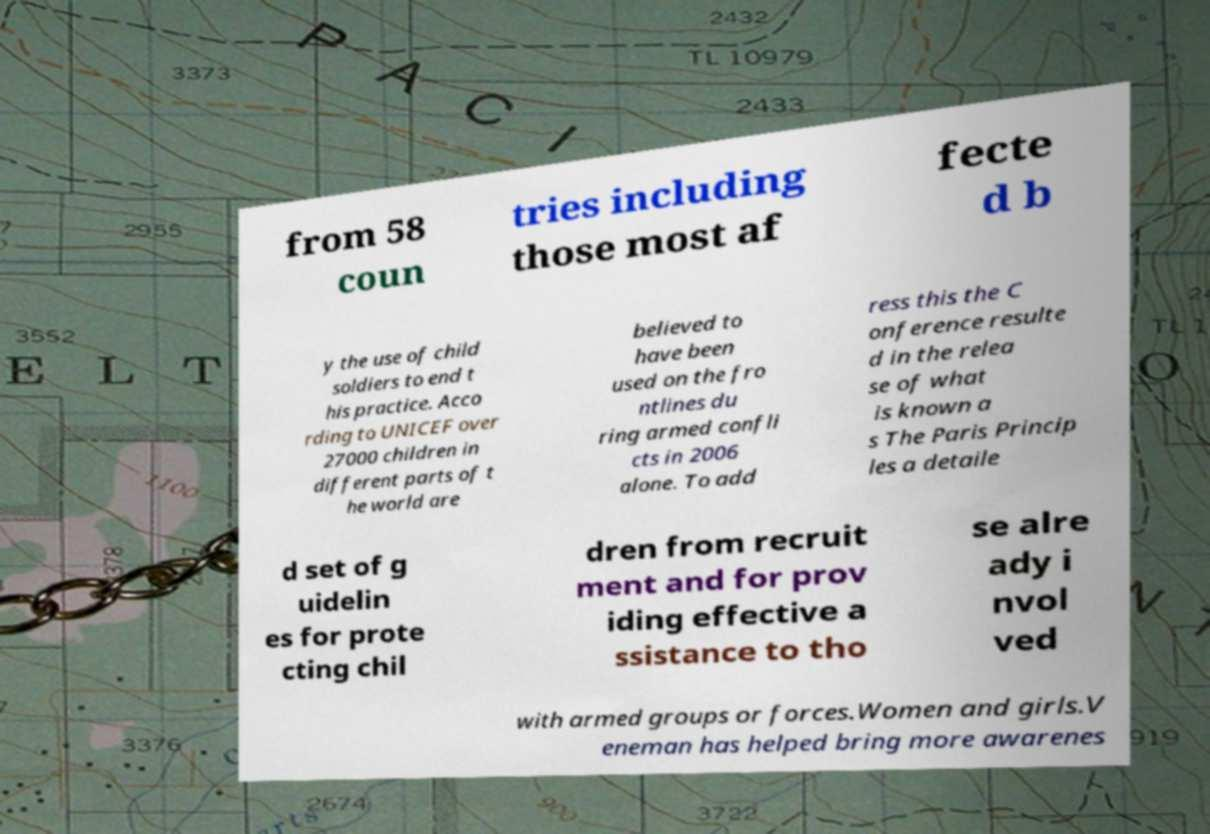There's text embedded in this image that I need extracted. Can you transcribe it verbatim? from 58 coun tries including those most af fecte d b y the use of child soldiers to end t his practice. Acco rding to UNICEF over 27000 children in different parts of t he world are believed to have been used on the fro ntlines du ring armed confli cts in 2006 alone. To add ress this the C onference resulte d in the relea se of what is known a s The Paris Princip les a detaile d set of g uidelin es for prote cting chil dren from recruit ment and for prov iding effective a ssistance to tho se alre ady i nvol ved with armed groups or forces.Women and girls.V eneman has helped bring more awarenes 